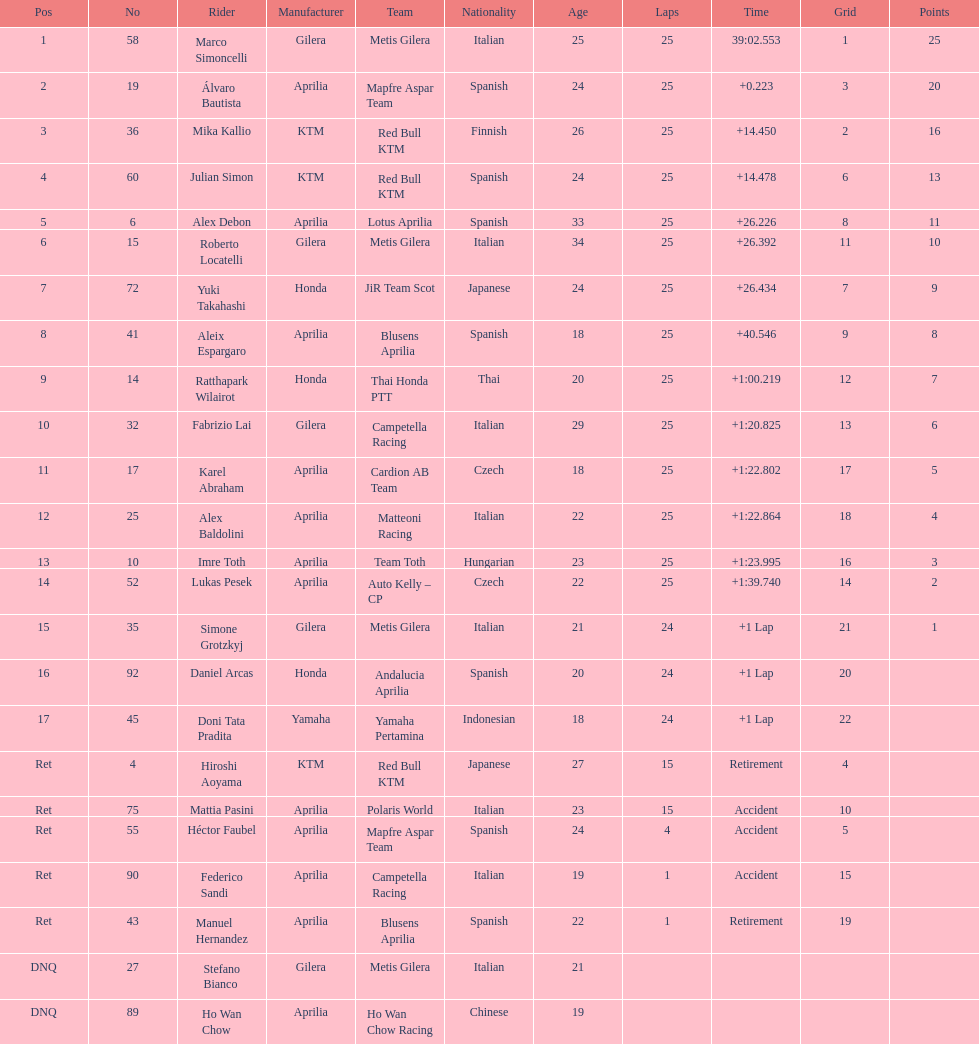What is the total number of rider? 24. 